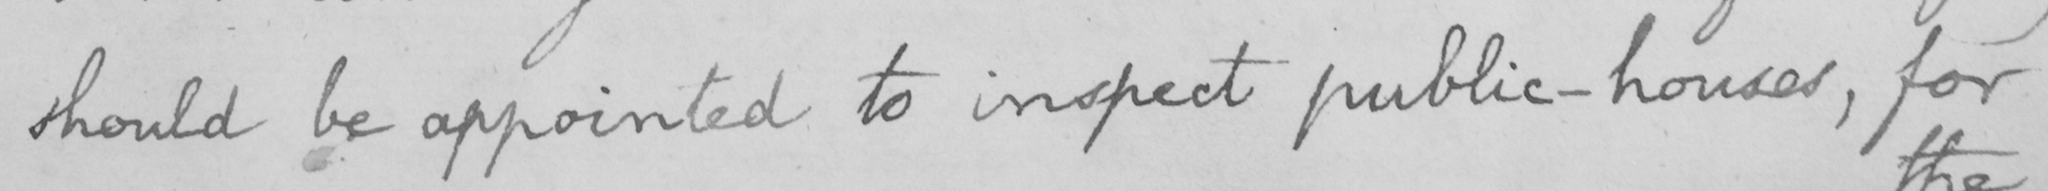Please transcribe the handwritten text in this image. should be appointed to inspect public-houses , for 